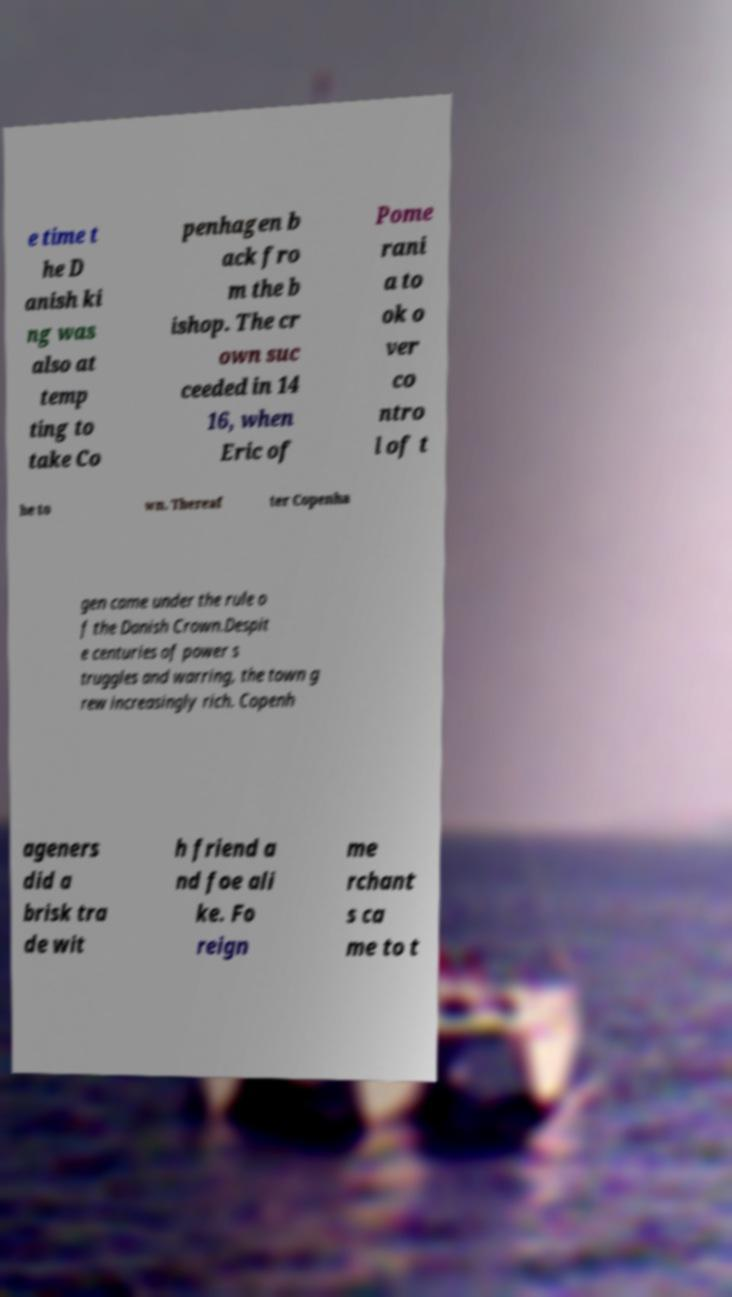For documentation purposes, I need the text within this image transcribed. Could you provide that? e time t he D anish ki ng was also at temp ting to take Co penhagen b ack fro m the b ishop. The cr own suc ceeded in 14 16, when Eric of Pome rani a to ok o ver co ntro l of t he to wn. Thereaf ter Copenha gen came under the rule o f the Danish Crown.Despit e centuries of power s truggles and warring, the town g rew increasingly rich. Copenh ageners did a brisk tra de wit h friend a nd foe ali ke. Fo reign me rchant s ca me to t 